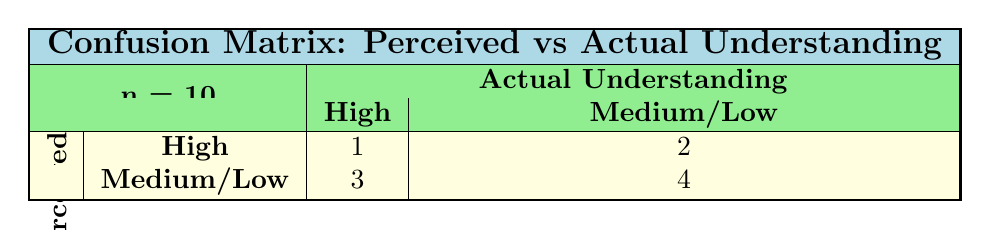What percentage of participants perceived their understanding as high while having actually high understanding? There is only one participant, James O'Sullivan, who had both perceived understanding and actual understanding as high. To find the percentage, we divide the number of such participants (1) by the total number of participants (10), and then multiply by 100: (1/10) * 100 = 10%.
Answer: 10% How many participants had a perceived understanding of medium or low but actually understood the workshop at a high level? Reviewing the table, we find that John Smith and Priya Patel had a perceived understanding of low and medium, respectively, but they actually understood at a high level. Counting these participants gives us a total of 2 participants.
Answer: 2 What is the total number of participants in each perceived understanding category (high, medium, low)? To find how many participants fall into each perceived understanding category, we count the occurrences: High = 4 (Emily, James, Sofia, Lucas), Medium = 3 (Chen, Carlos, Priya), Low = 3 (Aisha, Fatima, John). Therefore, the total number of participants in each category is: High - 4, Medium - 3, Low - 3.
Answer: High: 4, Medium: 3, Low: 3 Is it true that no participant with high perceived understanding had low actual understanding? By inspecting the table, none of the participants who perceived their understanding as high (Emily, James, Sofia, Lucas) had low actual understanding. Therefore, the statement is true.
Answer: Yes What is the difference between the number of participants who perceived their understanding as high and those who had a low perceived understanding? From the table, there are 4 participants with high perceived understanding and 3 with low perceived understanding. The difference is calculated as 4 (high) - 3 (low) = 1.
Answer: 1 